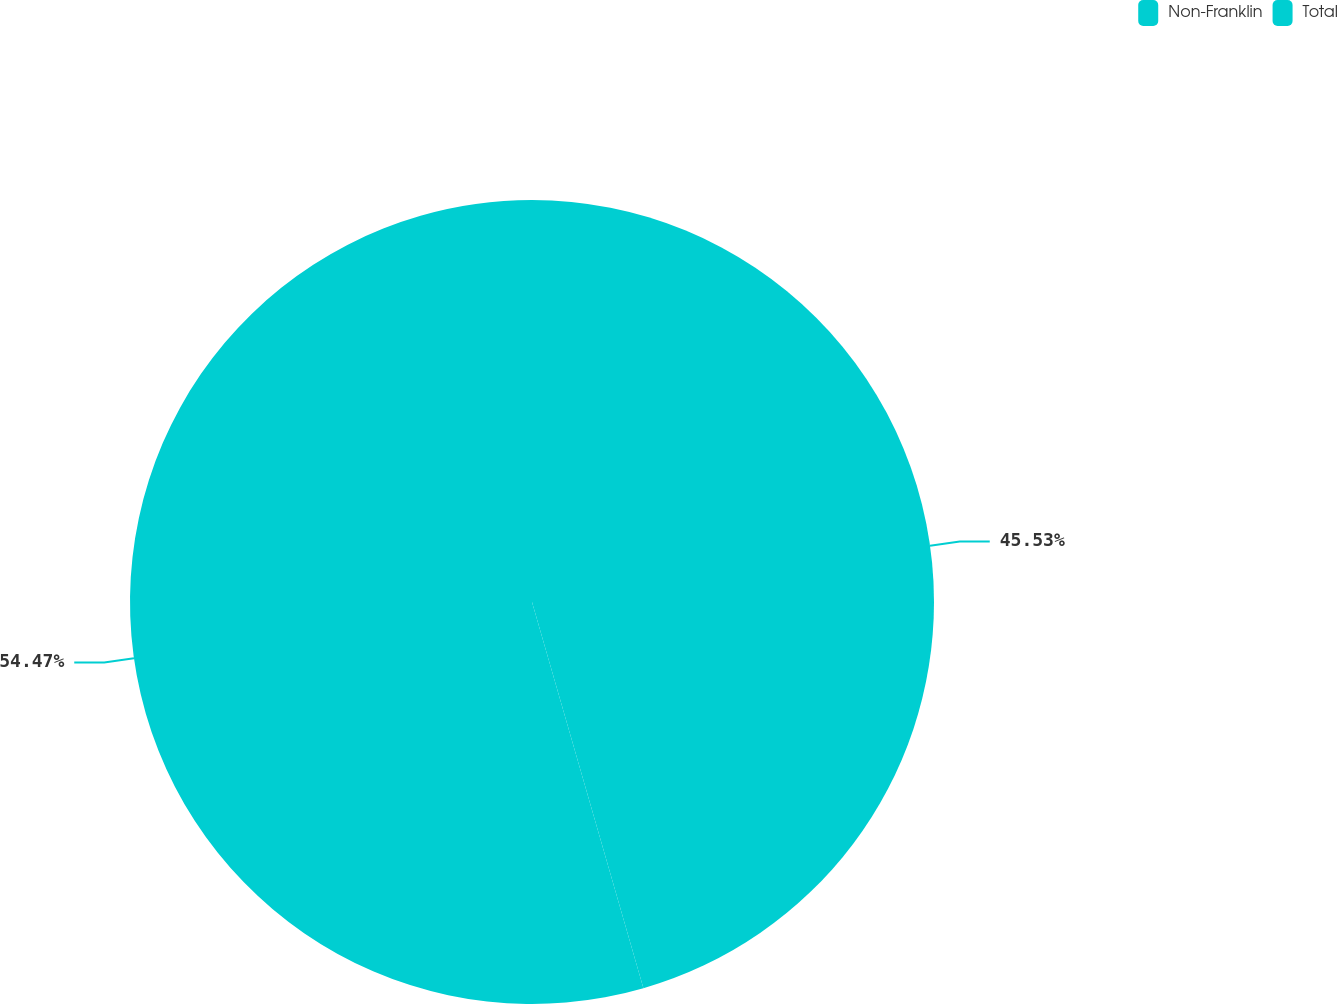Convert chart to OTSL. <chart><loc_0><loc_0><loc_500><loc_500><pie_chart><fcel>Non-Franklin<fcel>Total<nl><fcel>45.53%<fcel>54.47%<nl></chart> 